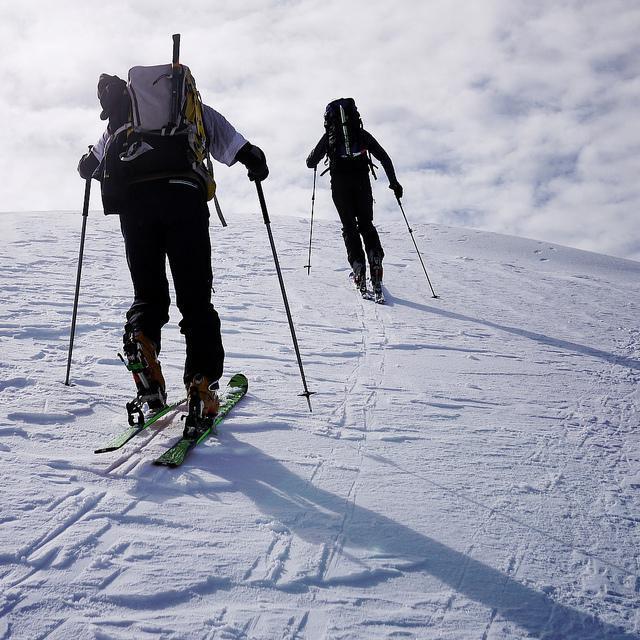How many people are in the picture?
Give a very brief answer. 2. How many backpacks are in the picture?
Give a very brief answer. 2. How many dogs are in the photo?
Give a very brief answer. 0. 